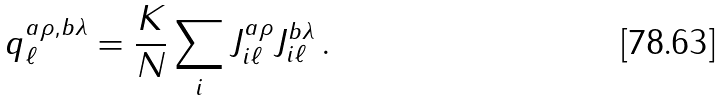Convert formula to latex. <formula><loc_0><loc_0><loc_500><loc_500>q _ { \ell } ^ { a \rho , b \lambda } = \frac { K } { N } \sum _ { i } J _ { i \ell } ^ { a \rho } J _ { i \ell } ^ { b \lambda } \, .</formula> 